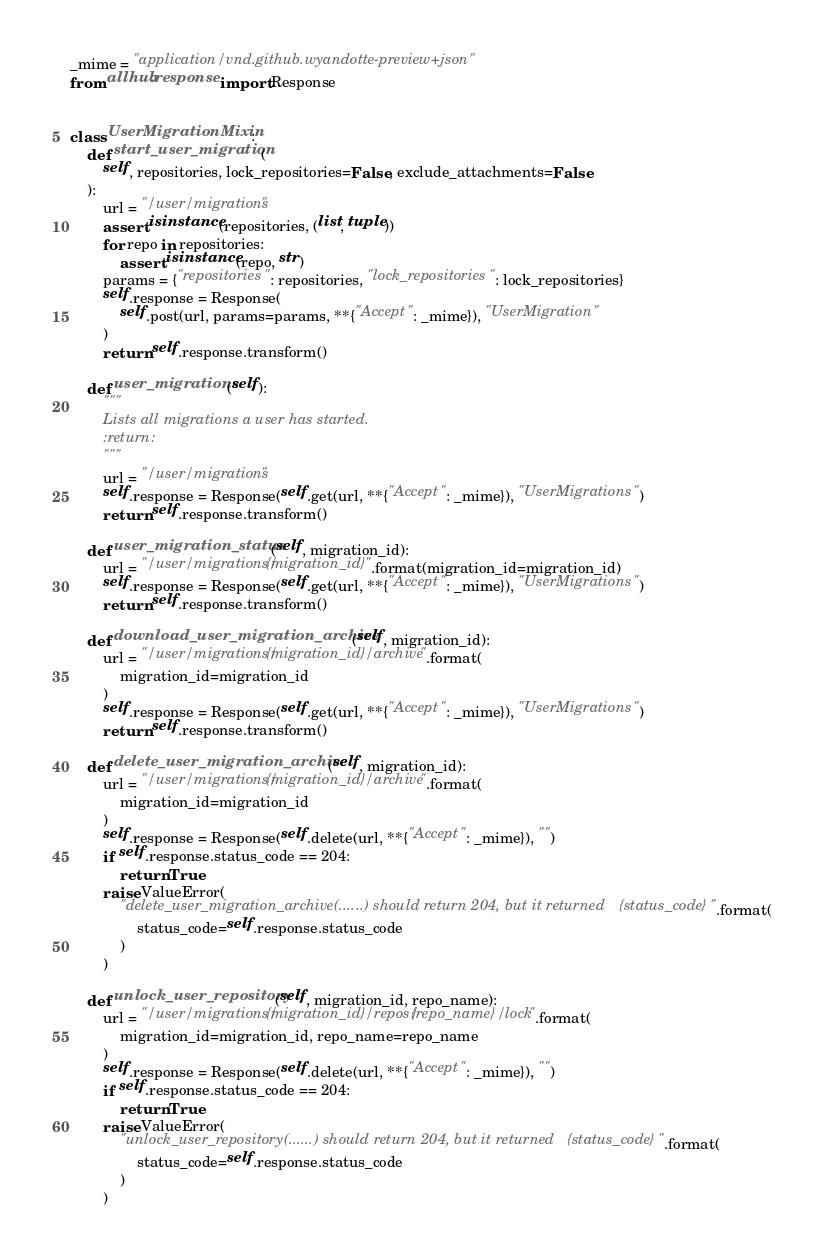<code> <loc_0><loc_0><loc_500><loc_500><_Python_>_mime = "application/vnd.github.wyandotte-preview+json"
from allhub.response import Response


class UserMigrationMixin:
    def start_user_migration(
        self, repositories, lock_repositories=False, exclude_attachments=False
    ):
        url = "/user/migrations"
        assert isinstance(repositories, (list, tuple))
        for repo in repositories:
            assert isinstance(repo, str)
        params = {"repositories": repositories, "lock_repositories": lock_repositories}
        self.response = Response(
            self.post(url, params=params, **{"Accept": _mime}), "UserMigration"
        )
        return self.response.transform()

    def user_migrations(self):
        """
        Lists all migrations a user has started.
        :return:
        """
        url = "/user/migrations"
        self.response = Response(self.get(url, **{"Accept": _mime}), "UserMigrations")
        return self.response.transform()

    def user_migration_status(self, migration_id):
        url = "/user/migrations/{migration_id}".format(migration_id=migration_id)
        self.response = Response(self.get(url, **{"Accept": _mime}), "UserMigrations")
        return self.response.transform()

    def download_user_migration_archive(self, migration_id):
        url = "/user/migrations/{migration_id}/archive".format(
            migration_id=migration_id
        )
        self.response = Response(self.get(url, **{"Accept": _mime}), "UserMigrations")
        return self.response.transform()

    def delete_user_migration_archive(self, migration_id):
        url = "/user/migrations/{migration_id}/archive".format(
            migration_id=migration_id
        )
        self.response = Response(self.delete(url, **{"Accept": _mime}), "")
        if self.response.status_code == 204:
            return True
        raise ValueError(
            "delete_user_migration_archive(......) should return 204, but it returned {status_code}".format(
                status_code=self.response.status_code
            )
        )

    def unlock_user_repository(self, migration_id, repo_name):
        url = "/user/migrations/{migration_id}/repos/{repo_name}/lock".format(
            migration_id=migration_id, repo_name=repo_name
        )
        self.response = Response(self.delete(url, **{"Accept": _mime}), "")
        if self.response.status_code == 204:
            return True
        raise ValueError(
            "unlock_user_repository(......) should return 204, but it returned {status_code}".format(
                status_code=self.response.status_code
            )
        )
</code> 